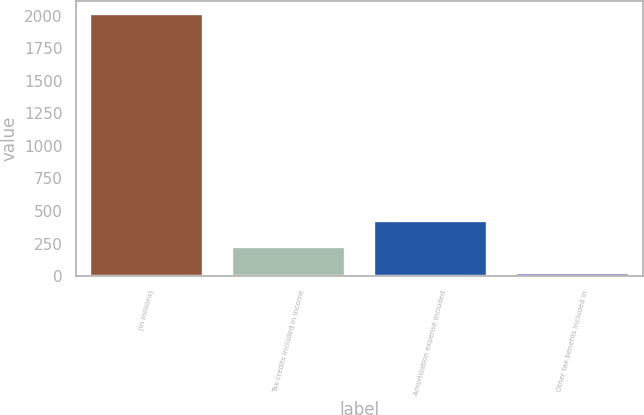<chart> <loc_0><loc_0><loc_500><loc_500><bar_chart><fcel>(in millions)<fcel>Tax credits included in income<fcel>Amortization expense included<fcel>Other tax benefits included in<nl><fcel>2016<fcel>220.5<fcel>420<fcel>21<nl></chart> 